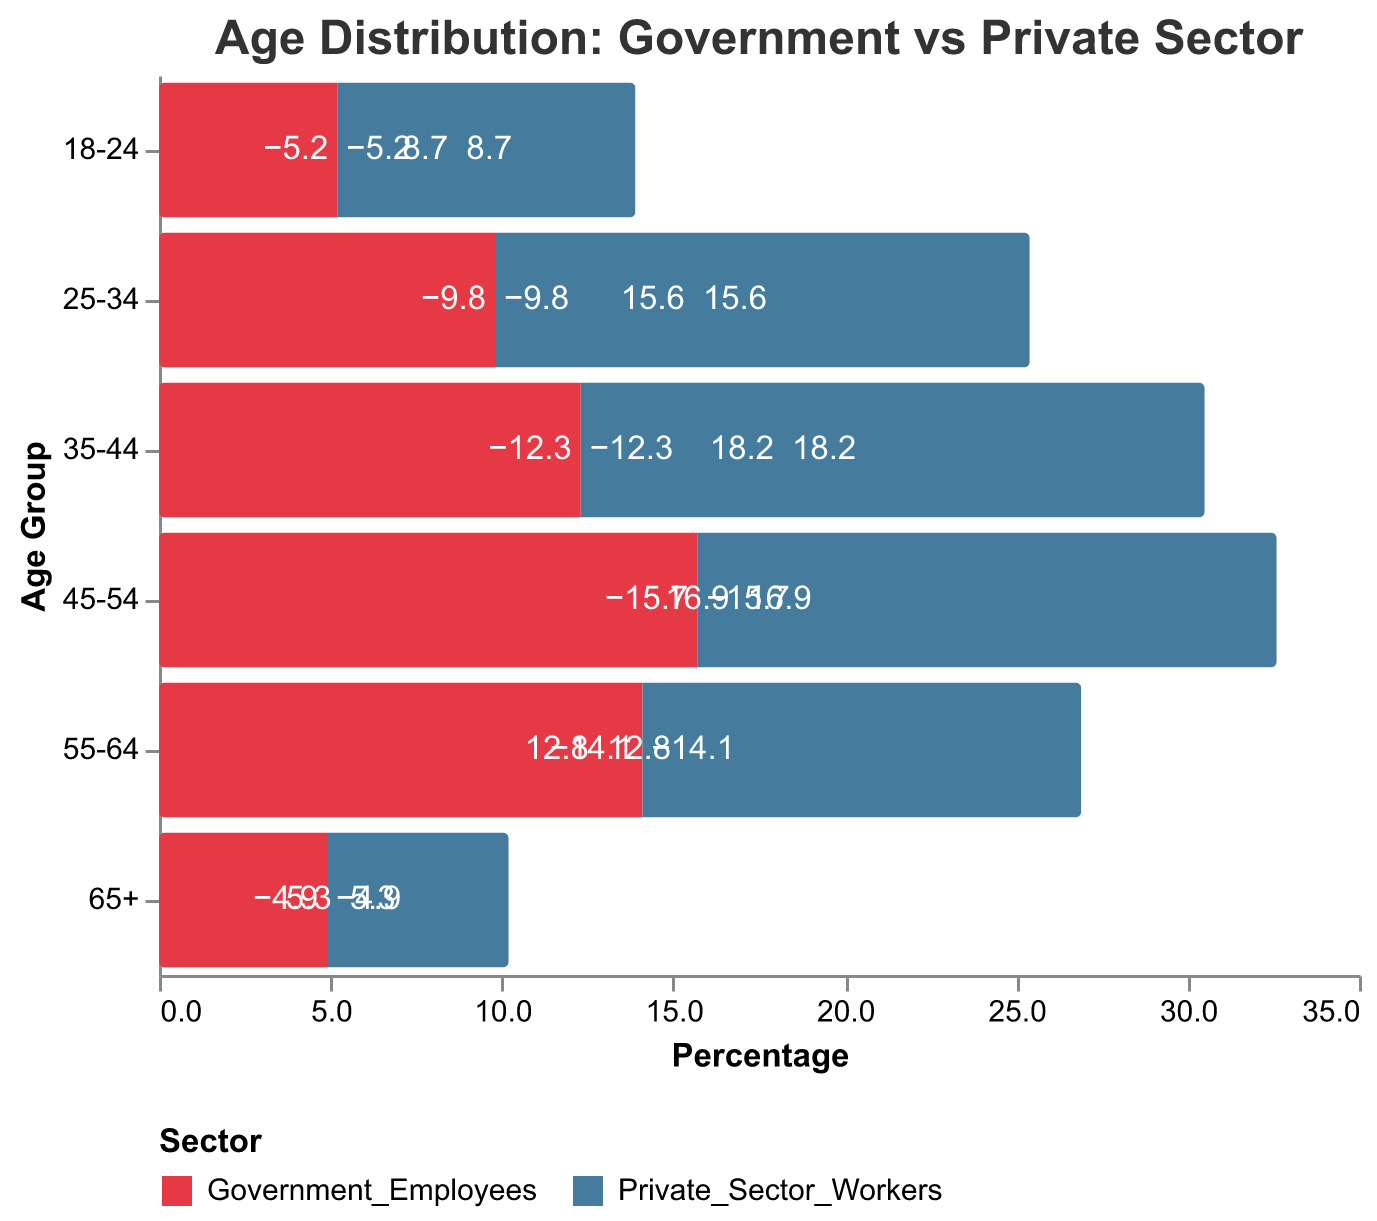What is the title of the figure? The title is displayed at the top of the figure, and it is "Age Distribution: Government vs Private Sector".
Answer: Age Distribution: Government vs Private Sector How are the colors used to differentiate between Government Employees and Private Sector Workers? The color legend at the bottom of the figure shows that Government Employees are represented in red while Private Sector Workers are shown in blue.
Answer: Red for Government Employees, Blue for Private Sector Workers Which age group has the highest percentage of Private Sector Workers? Observing the length of the blue bars, the age group 35-44 has the longest bar, indicating the highest percentage.
Answer: 35-44 Which age group has the highest percentage of Government Employees? By looking at the red bars, the age group 45-54 has the longest bar, indicating the highest percentage of Government Employees.
Answer: 45-54 What is the percentage of Private Sector Workers in the 55-64 age group? The blue bar corresponding to the age group 55-64 extends to 12.8%, which indicates the percentage of Private Sector Workers in this age group.
Answer: 12.8% What is the percentage of Government Employees in the 25-34 age group? The red bar corresponding to the age group 25-34 extends to -9.8% (displaying the negative value for Government Employees).
Answer: 9.8% Compare the percentage of Government Employees and Private Sector Workers in the 18-24 age group. The red bar for Government Employees is -5.2% and the blue bar for Private Sector Workers is 8.7%. Comparing these, Private Sector Workers have a higher percentage.
Answer: Private Sector Workers What is the sum of the percentages of Government Employees in the 35-44 and 45-54 age groups? Adding the percentages from the 35-44 (12.3%) and 45-54 (15.7%) age groups for Government Employees: 12.3 + 15.7.
Answer: 28.0% What is the difference in percentage between Private Sector Workers and Government Employees in the 65+ age group? The percentage of Private Sector Workers in the 65+ age group is 5.3%, and the Government Employees is 4.9%. The difference is calculated as 5.3 - 4.9.
Answer: 0.4% How does the visual representation of the 45-54 age group for Government Employees compare to Private Sector Workers? The red bar for Government Employees in the 45-54 age group is longer and extends to -15.7%, while the blue bar for Private Sector Workers reaches 16.9%. This indicates that the percentage values are very close but Private Sector Workers are slightly higher.
Answer: Private Sector Workers are slightly higher 